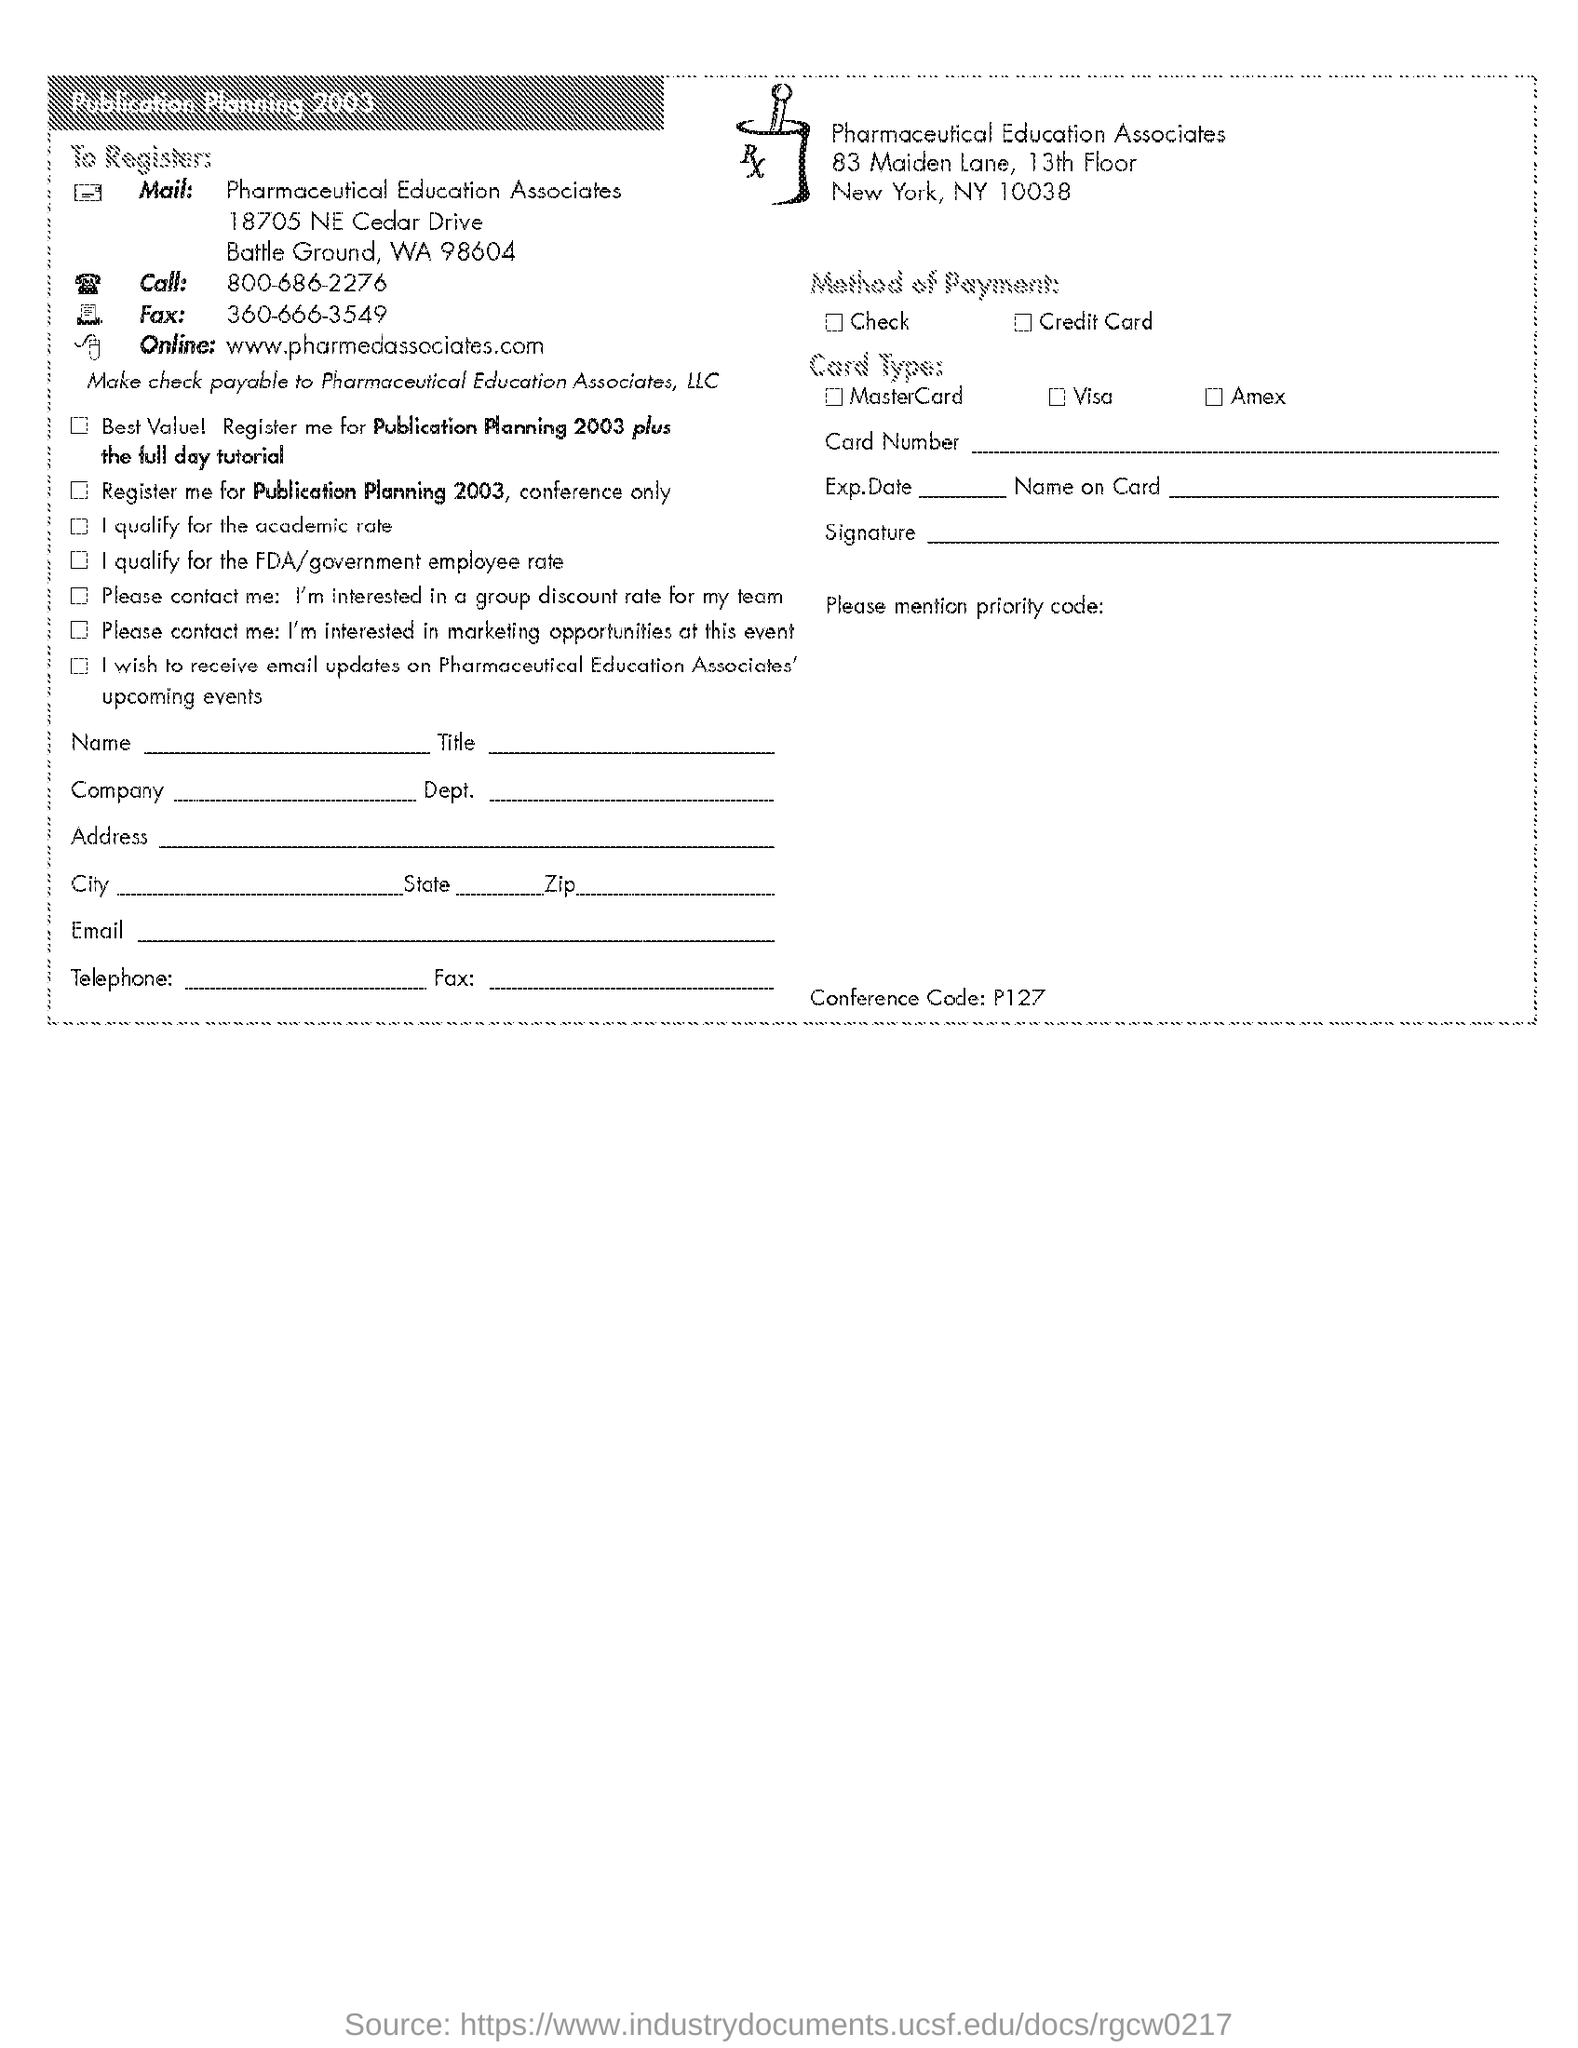What is the telephone number given?
Ensure brevity in your answer.  800-686-2276. What is the Fax number given?
Your response must be concise. 360-666-3549. What is the website mentioned to register?
Give a very brief answer. Www.pharmedassociates.com. To whom should the check be payable?
Offer a very short reply. Pharmaceutical Education Associates, LLC. Which firm is mentioned?
Offer a very short reply. Pharmaceutical Education Associates. What is the conference code?
Ensure brevity in your answer.  P127. 